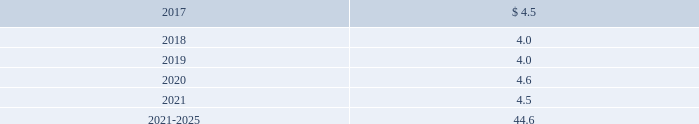Edwards lifesciences corporation notes to consolidated financial statements ( continued ) 12 .
Employee benefit plans ( continued ) equity and debt securities are valued at fair value based on quoted market prices reported on the active markets on which the individual securities are traded .
The insurance contracts are valued at the cash surrender value of the contracts , which is deemed to approximate its fair value .
The following benefit payments , which reflect expected future service , as appropriate , at december 31 , 2016 , are expected to be paid ( in millions ) : .
As of december 31 , 2016 , expected employer contributions for 2017 are $ 6.1 million .
Defined contribution plans the company 2019s employees in the united states and puerto rico are eligible to participate in a qualified defined contribution plan .
In the united states , participants may contribute up to 25% ( 25 % ) of their eligible compensation ( subject to tax code limitation ) to the plan .
Edwards lifesciences matches the first 3% ( 3 % ) of the participant 2019s annual eligible compensation contributed to the plan on a dollar-for-dollar basis .
Edwards lifesciences matches the next 2% ( 2 % ) of the participant 2019s annual eligible compensation to the plan on a 50% ( 50 % ) basis .
In puerto rico , participants may contribute up to 25% ( 25 % ) of their annual compensation ( subject to tax code limitation ) to the plan .
Edwards lifesciences matches the first 4% ( 4 % ) of participant 2019s annual eligible compensation contributed to the plan on a 50% ( 50 % ) basis .
The company also provides a 2% ( 2 % ) profit sharing contribution calculated on eligible earnings for each employee .
Matching contributions relating to edwards lifesciences employees were $ 17.3 million , $ 15.3 million , and $ 12.8 million in 2016 , 2015 , and 2014 , respectively .
The company also has nonqualified deferred compensation plans for a select group of employees .
The plans provide eligible participants the opportunity to defer eligible compensation to future dates specified by the participant with a return based on investment alternatives selected by the participant .
The amount accrued under these nonqualified plans was $ 46.7 million and $ 35.5 million at december 31 , 2016 and 2015 , respectively .
13 .
Common stock treasury stock in july 2014 , the board of directors approved a stock repurchase program authorizing the company to purchase up to $ 750.0 million of the company 2019s common stock .
In november 2016 , the board of directors approved a new stock repurchase program providing for an additional $ 1.0 billion of repurchases of our common stock .
The repurchase programs do not have an expiration date .
Stock repurchased under these programs may be used to offset obligations under the company 2019s employee stock-based benefit programs and stock-based business acquisitions , and will reduce the total shares outstanding .
During 2016 , 2015 , and 2014 , the company repurchased 7.3 million , 2.6 million , and 4.4 million shares , respectively , at an aggregate cost of $ 662.3 million , $ 280.1 million , and $ 300.9 million , respectively , including .
What was the percent change in matching contributions between 2014 and 2016? 
Computations: ((17.3 - 12.8) / 12.8)
Answer: 0.35156. Edwards lifesciences corporation notes to consolidated financial statements ( continued ) 12 .
Employee benefit plans ( continued ) equity and debt securities are valued at fair value based on quoted market prices reported on the active markets on which the individual securities are traded .
The insurance contracts are valued at the cash surrender value of the contracts , which is deemed to approximate its fair value .
The following benefit payments , which reflect expected future service , as appropriate , at december 31 , 2016 , are expected to be paid ( in millions ) : .
As of december 31 , 2016 , expected employer contributions for 2017 are $ 6.1 million .
Defined contribution plans the company 2019s employees in the united states and puerto rico are eligible to participate in a qualified defined contribution plan .
In the united states , participants may contribute up to 25% ( 25 % ) of their eligible compensation ( subject to tax code limitation ) to the plan .
Edwards lifesciences matches the first 3% ( 3 % ) of the participant 2019s annual eligible compensation contributed to the plan on a dollar-for-dollar basis .
Edwards lifesciences matches the next 2% ( 2 % ) of the participant 2019s annual eligible compensation to the plan on a 50% ( 50 % ) basis .
In puerto rico , participants may contribute up to 25% ( 25 % ) of their annual compensation ( subject to tax code limitation ) to the plan .
Edwards lifesciences matches the first 4% ( 4 % ) of participant 2019s annual eligible compensation contributed to the plan on a 50% ( 50 % ) basis .
The company also provides a 2% ( 2 % ) profit sharing contribution calculated on eligible earnings for each employee .
Matching contributions relating to edwards lifesciences employees were $ 17.3 million , $ 15.3 million , and $ 12.8 million in 2016 , 2015 , and 2014 , respectively .
The company also has nonqualified deferred compensation plans for a select group of employees .
The plans provide eligible participants the opportunity to defer eligible compensation to future dates specified by the participant with a return based on investment alternatives selected by the participant .
The amount accrued under these nonqualified plans was $ 46.7 million and $ 35.5 million at december 31 , 2016 and 2015 , respectively .
13 .
Common stock treasury stock in july 2014 , the board of directors approved a stock repurchase program authorizing the company to purchase up to $ 750.0 million of the company 2019s common stock .
In november 2016 , the board of directors approved a new stock repurchase program providing for an additional $ 1.0 billion of repurchases of our common stock .
The repurchase programs do not have an expiration date .
Stock repurchased under these programs may be used to offset obligations under the company 2019s employee stock-based benefit programs and stock-based business acquisitions , and will reduce the total shares outstanding .
During 2016 , 2015 , and 2014 , the company repurchased 7.3 million , 2.6 million , and 4.4 million shares , respectively , at an aggregate cost of $ 662.3 million , $ 280.1 million , and $ 300.9 million , respectively , including .
During 2016 what was the average price paid for the shares repurchased by the company? 
Computations: (662.3 / 7.3)
Answer: 90.72603. 